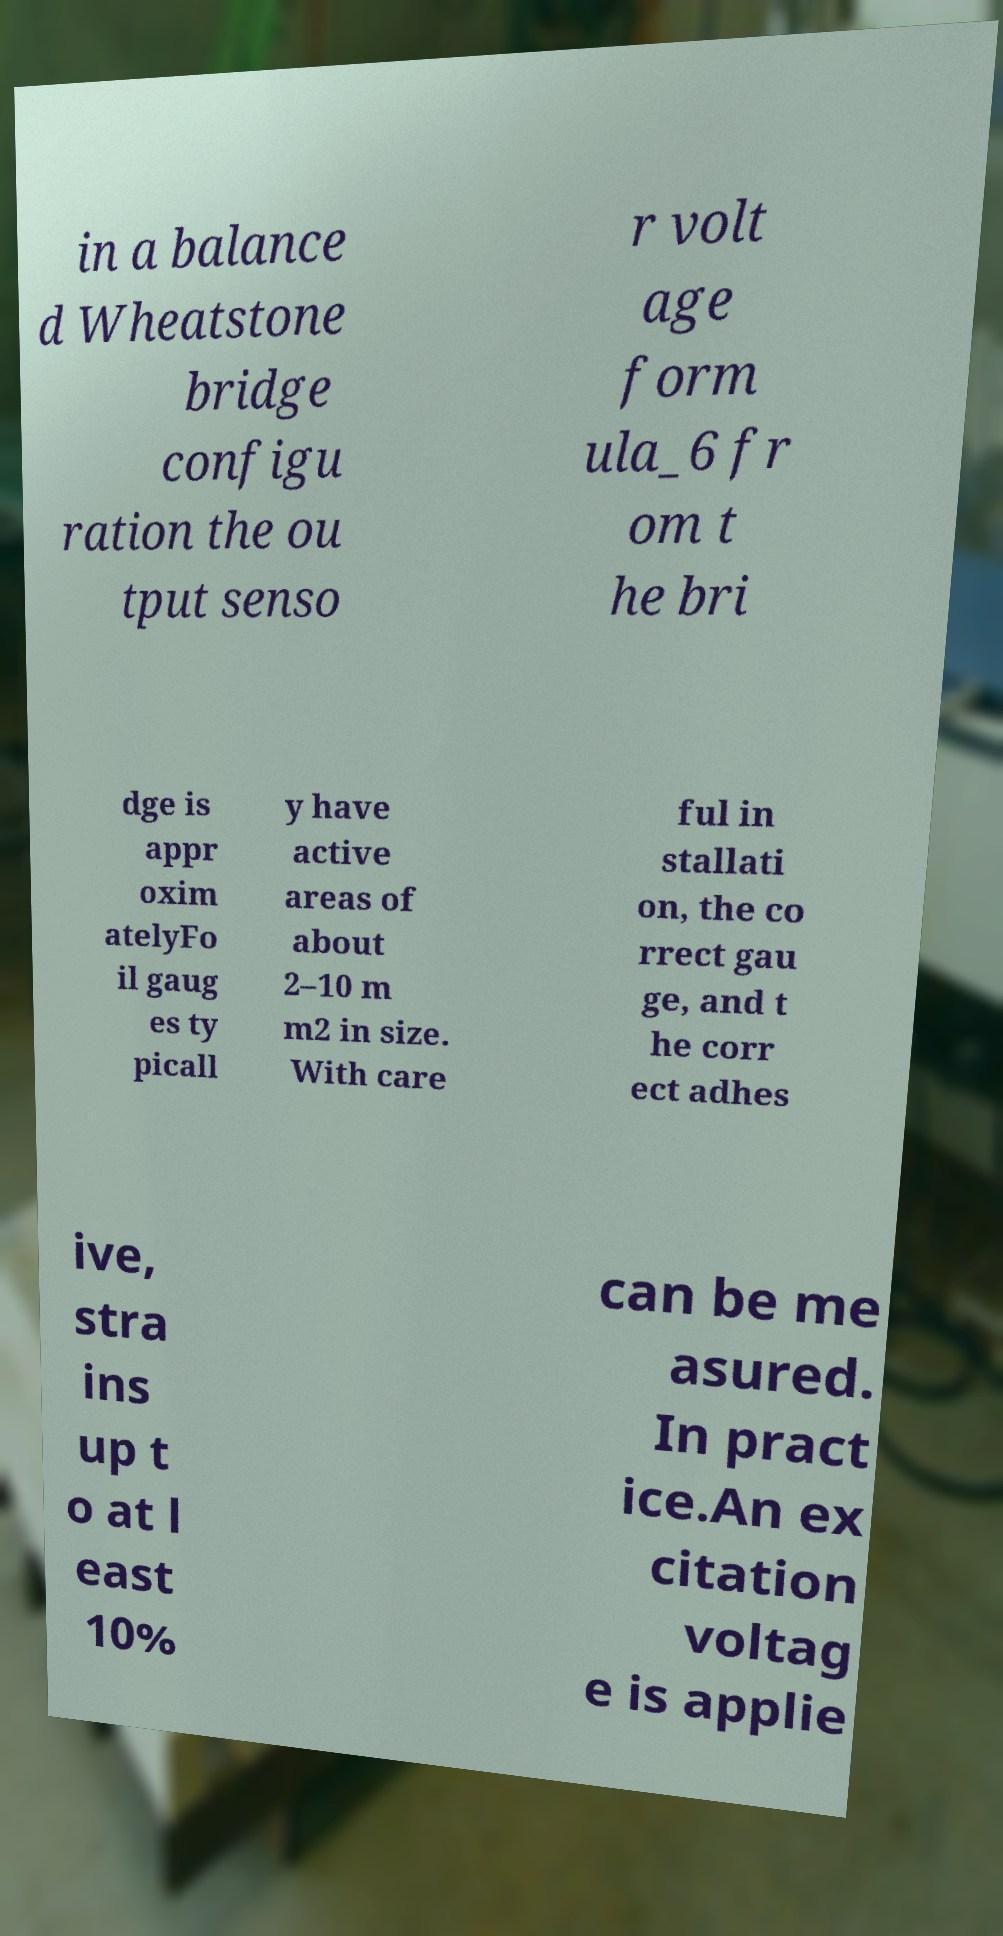I need the written content from this picture converted into text. Can you do that? in a balance d Wheatstone bridge configu ration the ou tput senso r volt age form ula_6 fr om t he bri dge is appr oxim atelyFo il gaug es ty picall y have active areas of about 2–10 m m2 in size. With care ful in stallati on, the co rrect gau ge, and t he corr ect adhes ive, stra ins up t o at l east 10% can be me asured. In pract ice.An ex citation voltag e is applie 